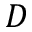Convert formula to latex. <formula><loc_0><loc_0><loc_500><loc_500>D</formula> 